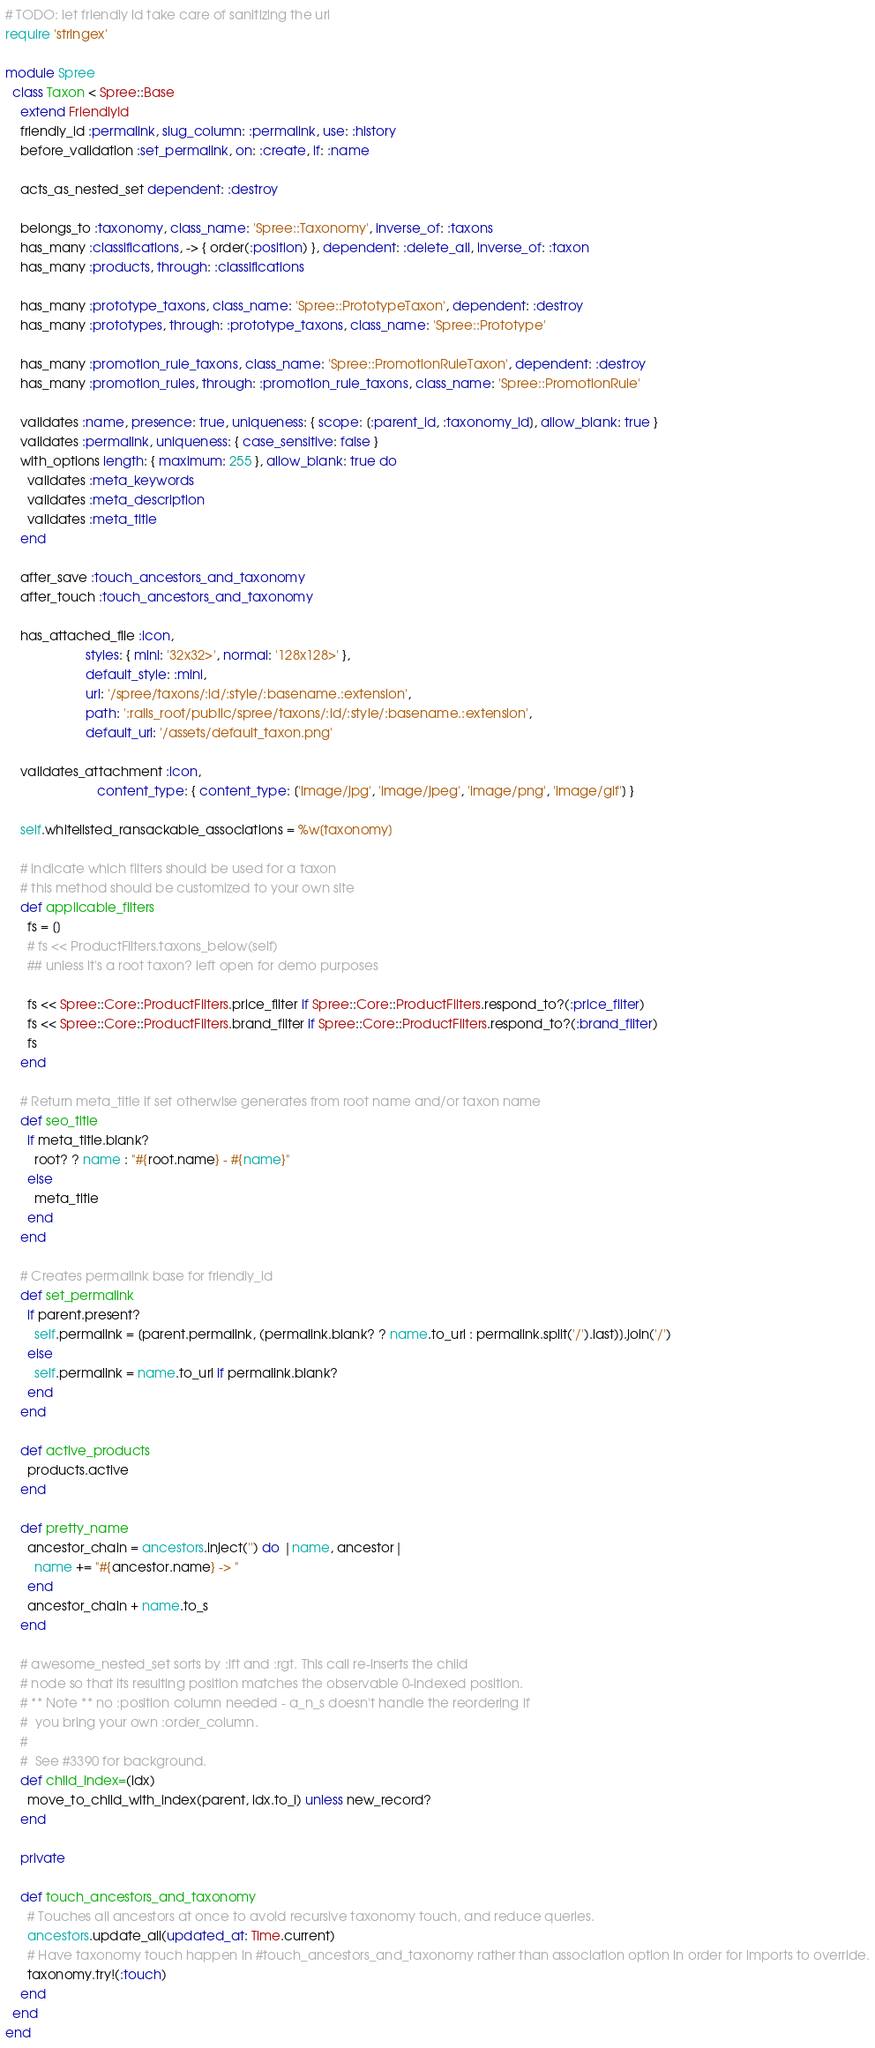Convert code to text. <code><loc_0><loc_0><loc_500><loc_500><_Ruby_># TODO: let friendly id take care of sanitizing the url
require 'stringex'

module Spree
  class Taxon < Spree::Base
    extend FriendlyId
    friendly_id :permalink, slug_column: :permalink, use: :history
    before_validation :set_permalink, on: :create, if: :name

    acts_as_nested_set dependent: :destroy

    belongs_to :taxonomy, class_name: 'Spree::Taxonomy', inverse_of: :taxons
    has_many :classifications, -> { order(:position) }, dependent: :delete_all, inverse_of: :taxon
    has_many :products, through: :classifications

    has_many :prototype_taxons, class_name: 'Spree::PrototypeTaxon', dependent: :destroy
    has_many :prototypes, through: :prototype_taxons, class_name: 'Spree::Prototype'

    has_many :promotion_rule_taxons, class_name: 'Spree::PromotionRuleTaxon', dependent: :destroy
    has_many :promotion_rules, through: :promotion_rule_taxons, class_name: 'Spree::PromotionRule'

    validates :name, presence: true, uniqueness: { scope: [:parent_id, :taxonomy_id], allow_blank: true }
    validates :permalink, uniqueness: { case_sensitive: false }
    with_options length: { maximum: 255 }, allow_blank: true do
      validates :meta_keywords
      validates :meta_description
      validates :meta_title
    end

    after_save :touch_ancestors_and_taxonomy
    after_touch :touch_ancestors_and_taxonomy

    has_attached_file :icon,
                      styles: { mini: '32x32>', normal: '128x128>' },
                      default_style: :mini,
                      url: '/spree/taxons/:id/:style/:basename.:extension',
                      path: ':rails_root/public/spree/taxons/:id/:style/:basename.:extension',
                      default_url: '/assets/default_taxon.png'

    validates_attachment :icon,
                         content_type: { content_type: ['image/jpg', 'image/jpeg', 'image/png', 'image/gif'] }

    self.whitelisted_ransackable_associations = %w[taxonomy]

    # indicate which filters should be used for a taxon
    # this method should be customized to your own site
    def applicable_filters
      fs = []
      # fs << ProductFilters.taxons_below(self)
      ## unless it's a root taxon? left open for demo purposes

      fs << Spree::Core::ProductFilters.price_filter if Spree::Core::ProductFilters.respond_to?(:price_filter)
      fs << Spree::Core::ProductFilters.brand_filter if Spree::Core::ProductFilters.respond_to?(:brand_filter)
      fs
    end

    # Return meta_title if set otherwise generates from root name and/or taxon name
    def seo_title
      if meta_title.blank?
        root? ? name : "#{root.name} - #{name}"
      else
        meta_title
      end
    end

    # Creates permalink base for friendly_id
    def set_permalink
      if parent.present?
        self.permalink = [parent.permalink, (permalink.blank? ? name.to_url : permalink.split('/').last)].join('/')
      else
        self.permalink = name.to_url if permalink.blank?
      end
    end

    def active_products
      products.active
    end

    def pretty_name
      ancestor_chain = ancestors.inject('') do |name, ancestor|
        name += "#{ancestor.name} -> "
      end
      ancestor_chain + name.to_s
    end

    # awesome_nested_set sorts by :lft and :rgt. This call re-inserts the child
    # node so that its resulting position matches the observable 0-indexed position.
    # ** Note ** no :position column needed - a_n_s doesn't handle the reordering if
    #  you bring your own :order_column.
    #
    #  See #3390 for background.
    def child_index=(idx)
      move_to_child_with_index(parent, idx.to_i) unless new_record?
    end

    private

    def touch_ancestors_and_taxonomy
      # Touches all ancestors at once to avoid recursive taxonomy touch, and reduce queries.
      ancestors.update_all(updated_at: Time.current)
      # Have taxonomy touch happen in #touch_ancestors_and_taxonomy rather than association option in order for imports to override.
      taxonomy.try!(:touch)
    end
  end
end
</code> 